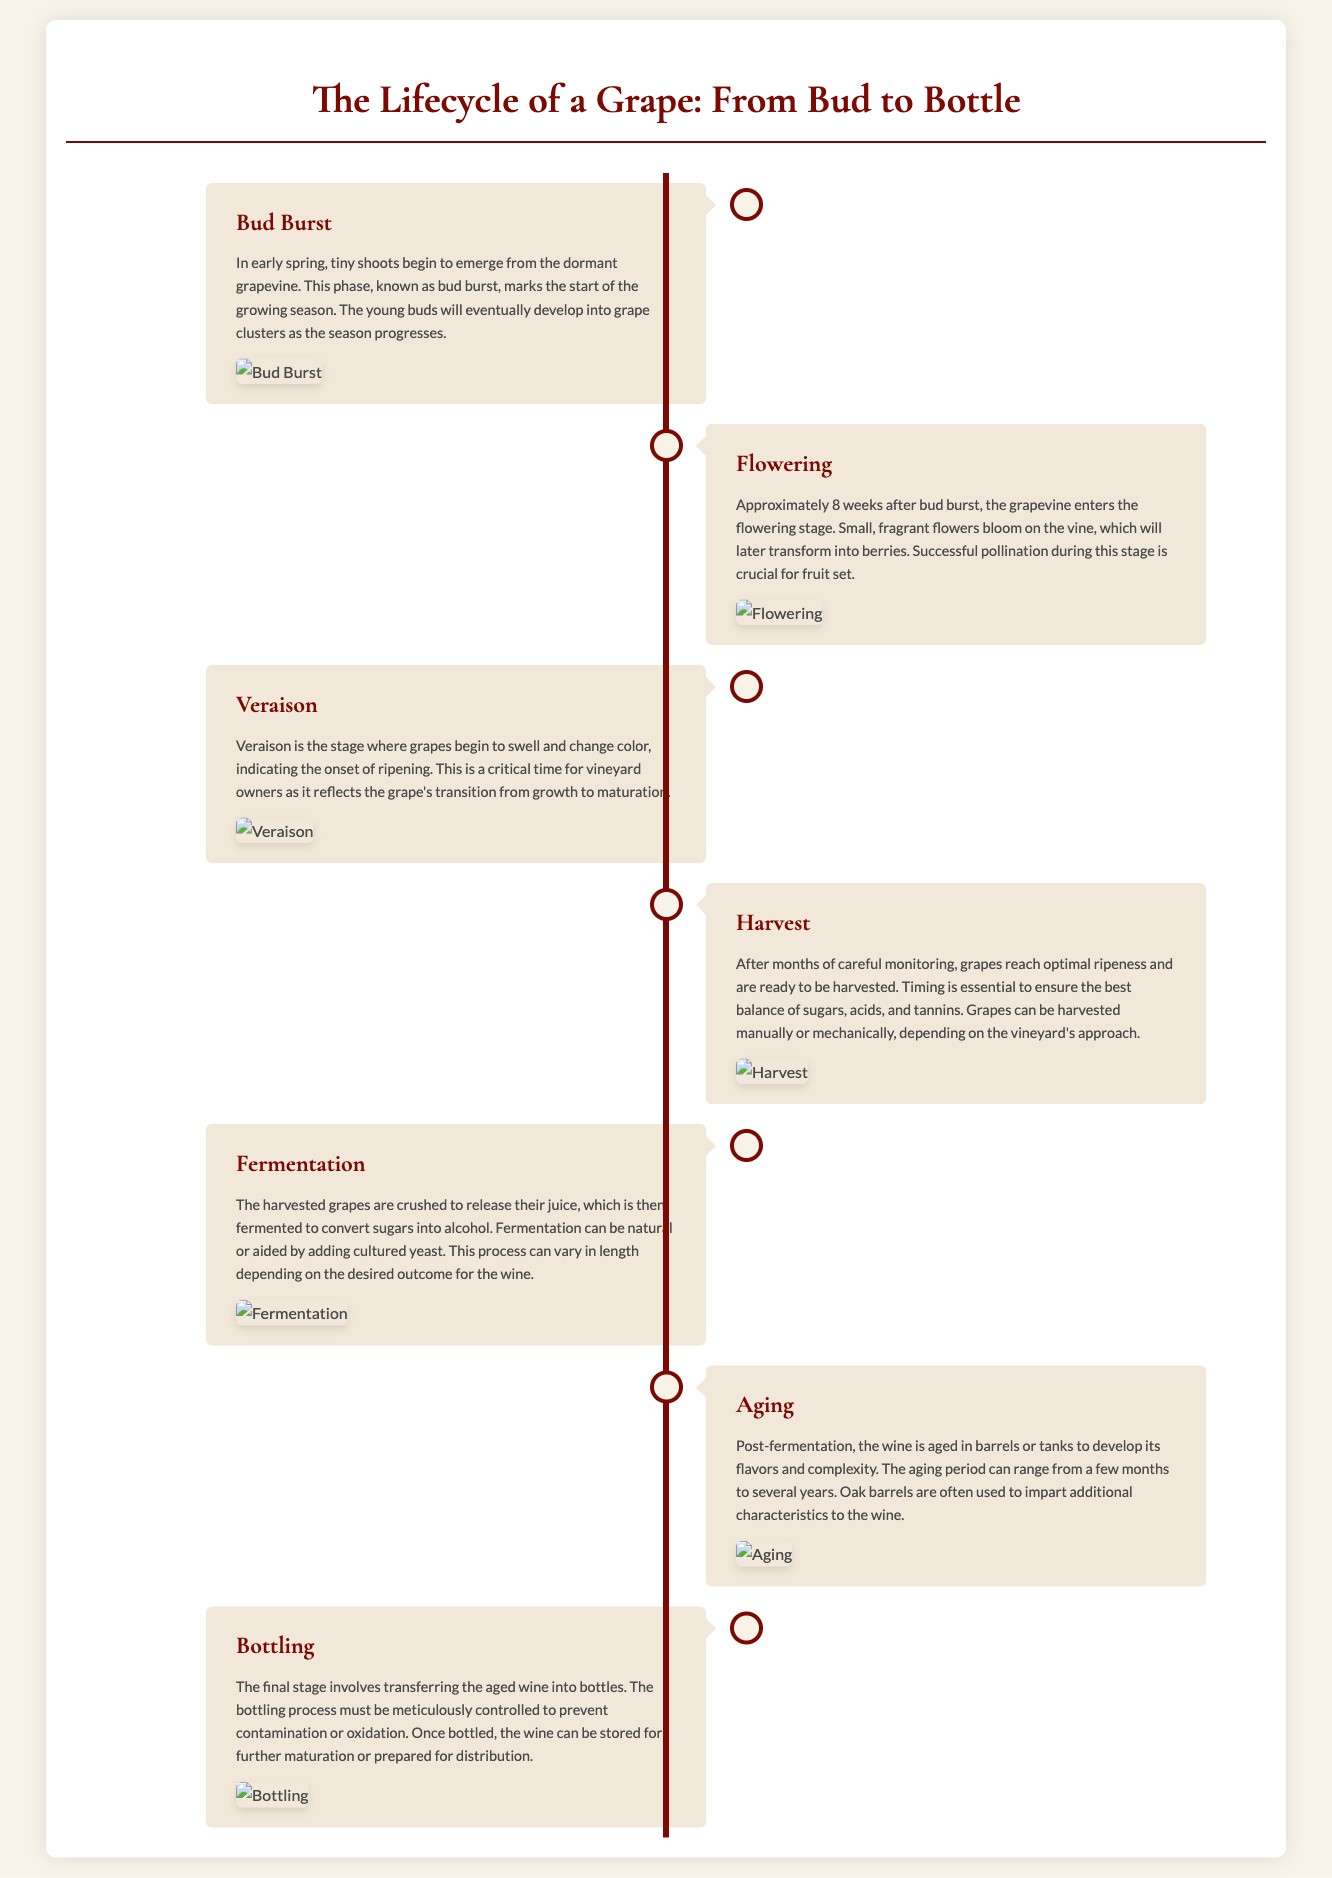What is the first stage of the grape lifecycle? The first stage mentioned in the document is "Bud Burst," where shoots begin to emerge from the dormant grapevine.
Answer: Bud Burst How many weeks after bud burst does flowering occur? The document states that flowering occurs approximately 8 weeks after bud burst.
Answer: 8 weeks What is the key factor during the flowering stage? The flowering stage emphasizes successful pollination for fruit set, which is crucial for grape development.
Answer: Pollination What happens during the veraison stage? During veraison, grapes begin to swell and change color, marking the onset of ripening.
Answer: Swell and change color What is the main goal during the harvest stage? The main goal during harvest is to ensure the best balance of sugars, acids, and tannins in the grapes.
Answer: Balance of sugars, acids, and tannins What process occurs after the grapes are harvested? After harvesting, the grapes are crushed and fermented to convert sugars into alcohol.
Answer: Fermentation In what containers is wine typically aged? The document mentions that wine is typically aged in barrels or tanks to develop its flavors and complexity.
Answer: Barrels or tanks What is vital during the bottling process? The bottling process needs to be meticulously controlled to prevent contamination or oxidation.
Answer: Control How long can the aging period range? The aging period mentioned in the document can range from a few months to several years.
Answer: A few months to several years 